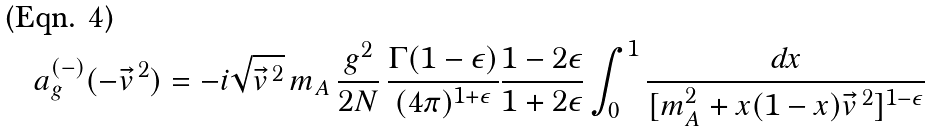Convert formula to latex. <formula><loc_0><loc_0><loc_500><loc_500>a _ { g } ^ { ( - ) } ( - \vec { v } ^ { \, 2 } ) = - i \sqrt { \vec { v } ^ { \, 2 } } \, m _ { A } \, \frac { g ^ { 2 } } { 2 N } \, \frac { \Gamma ( 1 - \epsilon ) } { ( 4 \pi ) ^ { 1 + \epsilon } } \frac { 1 - 2 \epsilon } { 1 + 2 \epsilon } \int _ { 0 } ^ { 1 } \frac { d x } { [ m _ { A } ^ { 2 } + x ( 1 - x ) \vec { v } ^ { \, 2 } ] ^ { 1 - \epsilon } }</formula> 